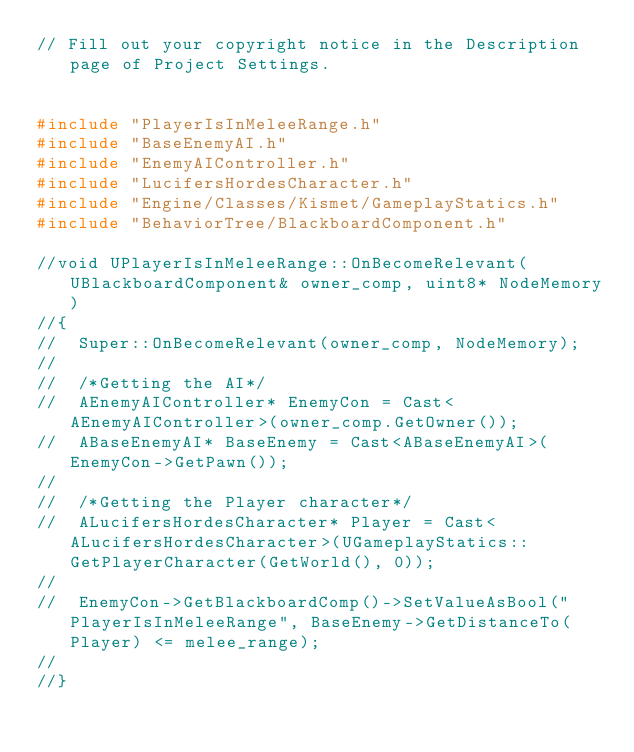Convert code to text. <code><loc_0><loc_0><loc_500><loc_500><_C++_>// Fill out your copyright notice in the Description page of Project Settings.


#include "PlayerIsInMeleeRange.h"
#include "BaseEnemyAI.h"
#include "EnemyAIController.h"
#include "LucifersHordesCharacter.h"
#include "Engine/Classes/Kismet/GameplayStatics.h"
#include "BehaviorTree/BlackboardComponent.h"

//void UPlayerIsInMeleeRange::OnBecomeRelevant(UBlackboardComponent& owner_comp, uint8* NodeMemory)
//{
//	Super::OnBecomeRelevant(owner_comp, NodeMemory);
//
//	/*Getting the AI*/
//	AEnemyAIController* EnemyCon = Cast<AEnemyAIController>(owner_comp.GetOwner());
//	ABaseEnemyAI* BaseEnemy = Cast<ABaseEnemyAI>(EnemyCon->GetPawn()); 
//
//	/*Getting the Player character*/
//	ALucifersHordesCharacter* Player = Cast<ALucifersHordesCharacter>(UGameplayStatics::GetPlayerCharacter(GetWorld(), 0)); 
//
//	EnemyCon->GetBlackboardComp()->SetValueAsBool("PlayerIsInMeleeRange", BaseEnemy->GetDistanceTo(Player) <= melee_range); 
//
//}
</code> 